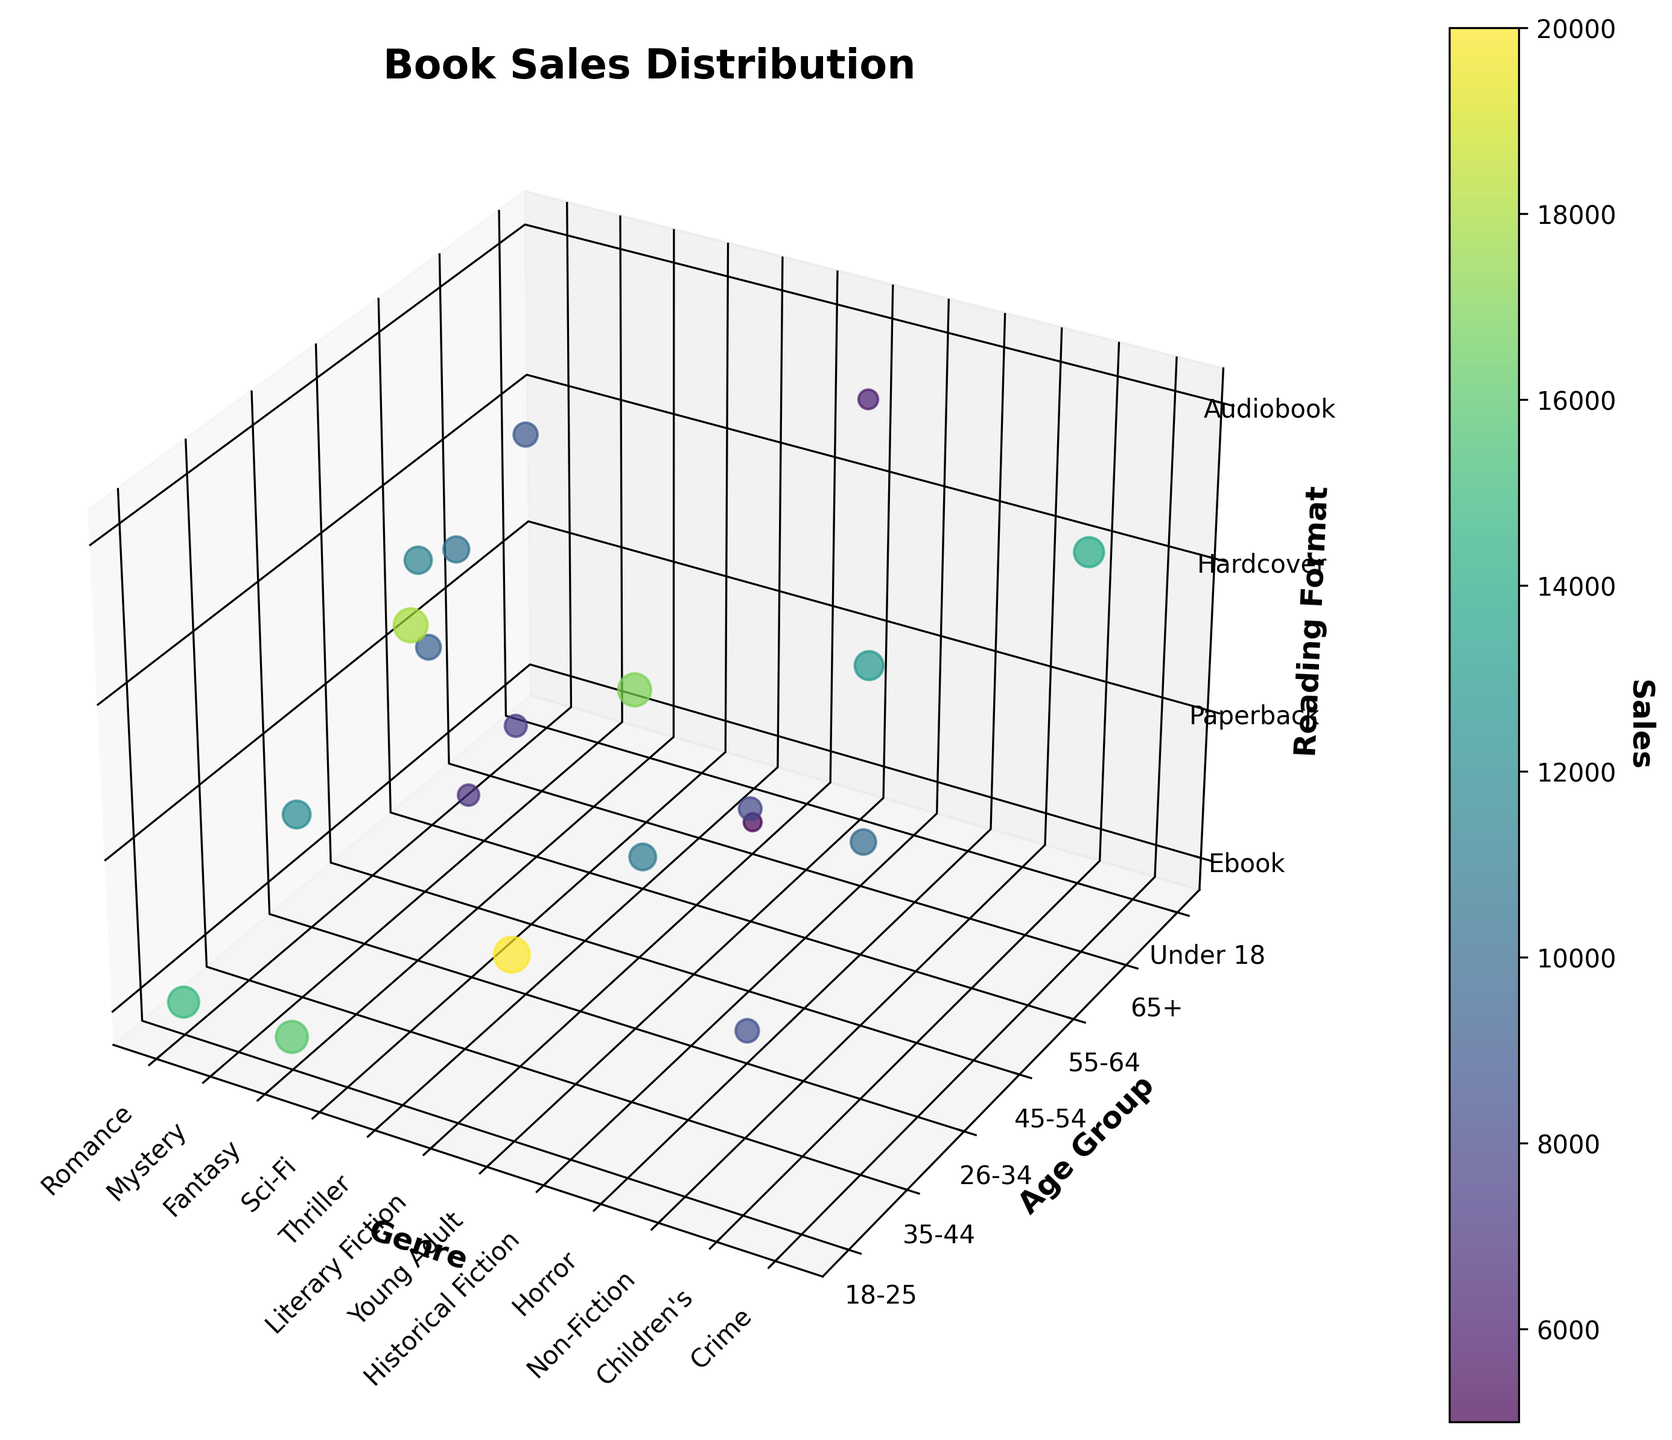What genre has the highest sales in the 18-25 age group? Locate the points corresponding to the 18-25 age group on the Y-axis and check the color intensity of the dots. Identify the genre with the highest sales value based on color
Answer: Young Adult Which age group shows the highest book sales in the Audiobook format? Find the points marked for the Audiobook format on the Z-axis and compare the colors/intensity of these points across different age groups to identify the highest sales value
Answer: 35-44 Compare the sales of Hardcover format between the genres Literary Fiction and Young Adult. Which has higher sales? Identify the points for the Hardcover format in the Z-axis and compare their sales color/intensity between Literary Fiction and Young Adult
Answer: Young Adult Which reading format shows the highest sales within the 26-34 age group? Locate the points corresponding to the 26-34 age group on the Y-axis, then compare the sales color/intensity among different reading formats on the Z-axis
Answer: Hardcover In the 65+ age group, for which genre is the sales figure the lowest? Check the points for the 65+ age group on the Y-axis. Compare the sales color/intensity for different genres to find the least intense color
Answer: Literary Fiction How do sales of eBooks in the 55-64 age group compare to paperbacks in the same age group? Look at the points on the Y-axis for the 55-64 age group. Compare the color intensity between eBooks and paperbacks
Answer: eBooks have higher sales Which genre has the least sales overall? Identify and compare the intensity/color across all points for each genre to find the one with the least intense color overall
Answer: Historical Fiction Analyze the difference in sales between Sci-Fi and Crime genres in the 45-54 age group Locate the points for the 45-54 age group on the Y-axis and compare the sales color/intensity between the Sci-Fi and Crime genres
Answer: Crime has higher sales Which genre has a higher sales value in eBooks, Romance or Horror? Locate the points on the Z-axis for eBooks and compare the sales color/intensity between Romance and Horror genres
Answer: Romance Which age group has the lowest sales in Paperback format? Look at the points on the Z-axis for the Paperback format and identify the age group with the least intense color
Answer: 45-54 